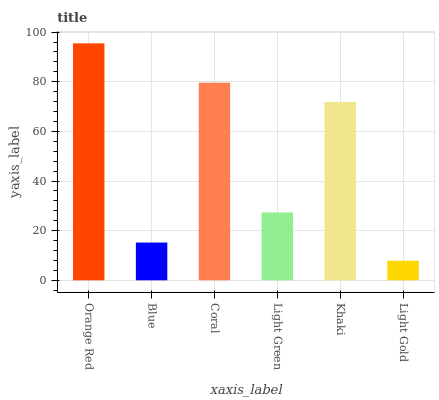Is Light Gold the minimum?
Answer yes or no. Yes. Is Orange Red the maximum?
Answer yes or no. Yes. Is Blue the minimum?
Answer yes or no. No. Is Blue the maximum?
Answer yes or no. No. Is Orange Red greater than Blue?
Answer yes or no. Yes. Is Blue less than Orange Red?
Answer yes or no. Yes. Is Blue greater than Orange Red?
Answer yes or no. No. Is Orange Red less than Blue?
Answer yes or no. No. Is Khaki the high median?
Answer yes or no. Yes. Is Light Green the low median?
Answer yes or no. Yes. Is Coral the high median?
Answer yes or no. No. Is Orange Red the low median?
Answer yes or no. No. 